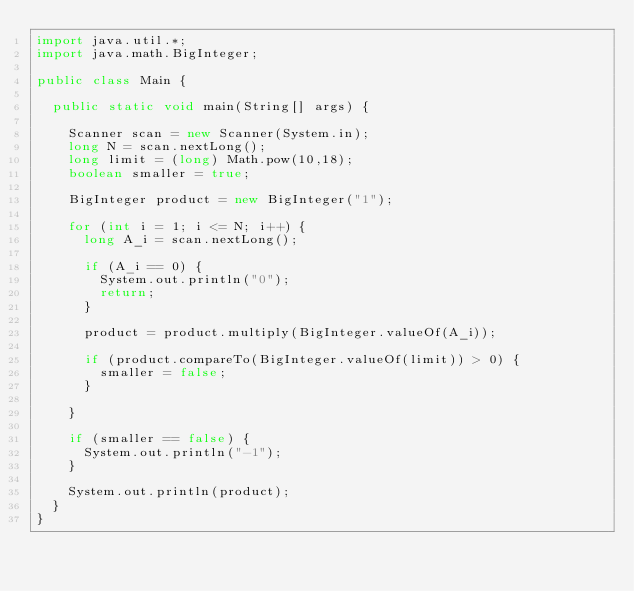<code> <loc_0><loc_0><loc_500><loc_500><_Java_>import java.util.*;
import java.math.BigInteger;

public class Main {
  
  public static void main(String[] args) {
    
    Scanner scan = new Scanner(System.in);
    long N = scan.nextLong();
    long limit = (long) Math.pow(10,18);
    boolean smaller = true;
    
    BigInteger product = new BigInteger("1");
    
    for (int i = 1; i <= N; i++) {
      long A_i = scan.nextLong();
      
      if (A_i == 0) {
        System.out.println("0");
        return;
      }
      
      product = product.multiply(BigInteger.valueOf(A_i));
      
      if (product.compareTo(BigInteger.valueOf(limit)) > 0) {
        smaller = false;
      }
      
    }
    
    if (smaller == false) {
      System.out.println("-1");
    }
    
    System.out.println(product);
  }
}
</code> 